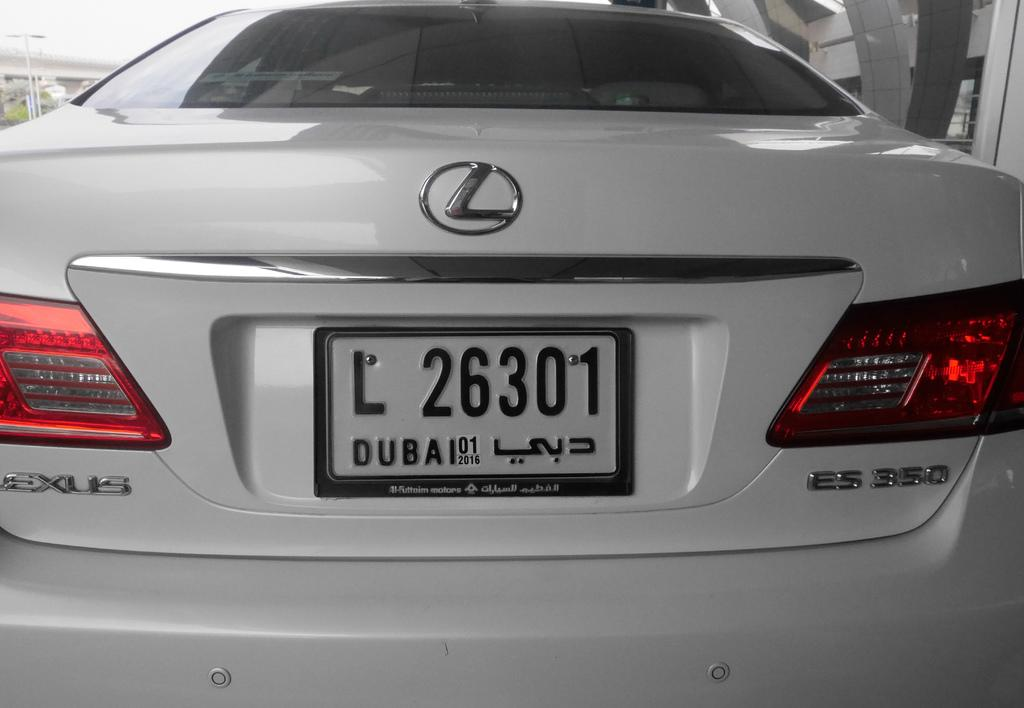Provide a one-sentence caption for the provided image. A white car has a license plate displaying L 26301. 